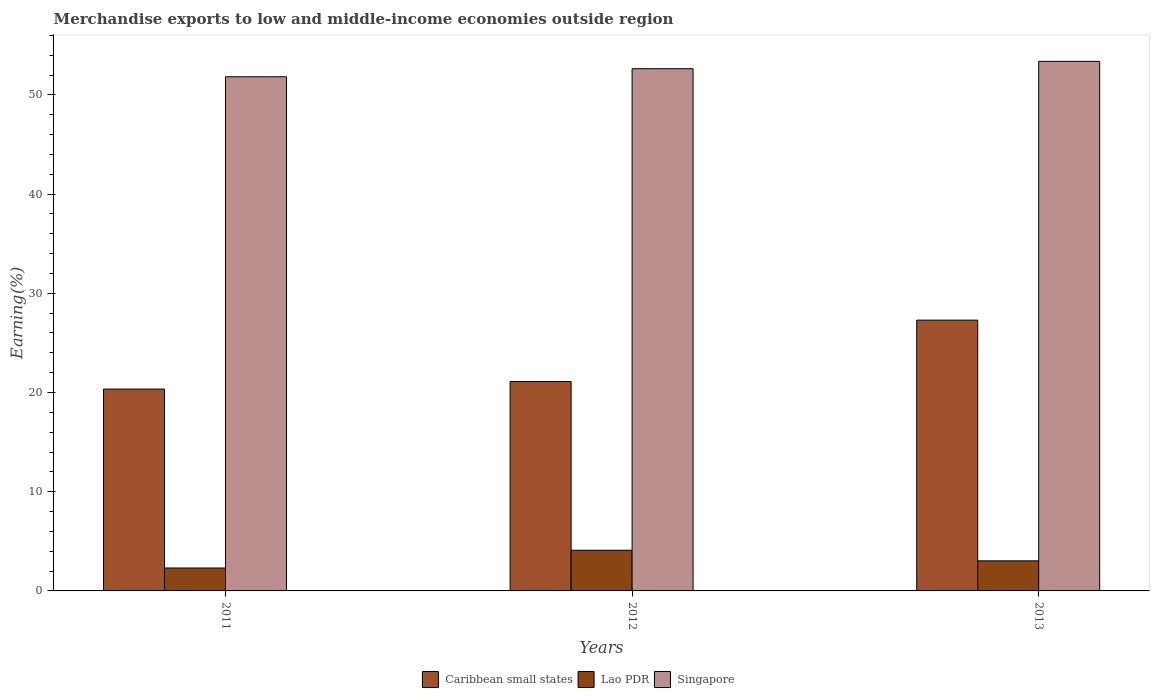How many groups of bars are there?
Ensure brevity in your answer.  3. Are the number of bars on each tick of the X-axis equal?
Give a very brief answer. Yes. How many bars are there on the 2nd tick from the left?
Your response must be concise. 3. What is the label of the 2nd group of bars from the left?
Keep it short and to the point. 2012. In how many cases, is the number of bars for a given year not equal to the number of legend labels?
Ensure brevity in your answer.  0. What is the percentage of amount earned from merchandise exports in Caribbean small states in 2013?
Offer a very short reply. 27.3. Across all years, what is the maximum percentage of amount earned from merchandise exports in Lao PDR?
Provide a succinct answer. 4.1. Across all years, what is the minimum percentage of amount earned from merchandise exports in Caribbean small states?
Ensure brevity in your answer.  20.35. In which year was the percentage of amount earned from merchandise exports in Caribbean small states minimum?
Your response must be concise. 2011. What is the total percentage of amount earned from merchandise exports in Singapore in the graph?
Your answer should be compact. 157.85. What is the difference between the percentage of amount earned from merchandise exports in Caribbean small states in 2011 and that in 2012?
Your answer should be very brief. -0.76. What is the difference between the percentage of amount earned from merchandise exports in Singapore in 2011 and the percentage of amount earned from merchandise exports in Lao PDR in 2012?
Your answer should be very brief. 47.73. What is the average percentage of amount earned from merchandise exports in Singapore per year?
Ensure brevity in your answer.  52.62. In the year 2013, what is the difference between the percentage of amount earned from merchandise exports in Singapore and percentage of amount earned from merchandise exports in Lao PDR?
Keep it short and to the point. 50.35. What is the ratio of the percentage of amount earned from merchandise exports in Caribbean small states in 2011 to that in 2012?
Your answer should be very brief. 0.96. Is the percentage of amount earned from merchandise exports in Caribbean small states in 2011 less than that in 2012?
Your answer should be very brief. Yes. Is the difference between the percentage of amount earned from merchandise exports in Singapore in 2011 and 2012 greater than the difference between the percentage of amount earned from merchandise exports in Lao PDR in 2011 and 2012?
Your answer should be compact. Yes. What is the difference between the highest and the second highest percentage of amount earned from merchandise exports in Singapore?
Offer a terse response. 0.74. What is the difference between the highest and the lowest percentage of amount earned from merchandise exports in Singapore?
Your answer should be compact. 1.55. Is the sum of the percentage of amount earned from merchandise exports in Caribbean small states in 2012 and 2013 greater than the maximum percentage of amount earned from merchandise exports in Singapore across all years?
Ensure brevity in your answer.  No. What does the 1st bar from the left in 2013 represents?
Give a very brief answer. Caribbean small states. What does the 1st bar from the right in 2013 represents?
Offer a very short reply. Singapore. How many bars are there?
Offer a terse response. 9. How many years are there in the graph?
Your answer should be compact. 3. What is the difference between two consecutive major ticks on the Y-axis?
Make the answer very short. 10. Are the values on the major ticks of Y-axis written in scientific E-notation?
Ensure brevity in your answer.  No. Does the graph contain grids?
Your answer should be compact. No. Where does the legend appear in the graph?
Your answer should be very brief. Bottom center. How many legend labels are there?
Make the answer very short. 3. How are the legend labels stacked?
Keep it short and to the point. Horizontal. What is the title of the graph?
Provide a succinct answer. Merchandise exports to low and middle-income economies outside region. Does "Papua New Guinea" appear as one of the legend labels in the graph?
Keep it short and to the point. No. What is the label or title of the X-axis?
Provide a short and direct response. Years. What is the label or title of the Y-axis?
Provide a short and direct response. Earning(%). What is the Earning(%) of Caribbean small states in 2011?
Make the answer very short. 20.35. What is the Earning(%) of Lao PDR in 2011?
Provide a short and direct response. 2.31. What is the Earning(%) in Singapore in 2011?
Your response must be concise. 51.83. What is the Earning(%) in Caribbean small states in 2012?
Keep it short and to the point. 21.1. What is the Earning(%) in Lao PDR in 2012?
Ensure brevity in your answer.  4.1. What is the Earning(%) in Singapore in 2012?
Your answer should be compact. 52.64. What is the Earning(%) in Caribbean small states in 2013?
Ensure brevity in your answer.  27.3. What is the Earning(%) of Lao PDR in 2013?
Provide a succinct answer. 3.03. What is the Earning(%) of Singapore in 2013?
Your answer should be very brief. 53.38. Across all years, what is the maximum Earning(%) in Caribbean small states?
Offer a very short reply. 27.3. Across all years, what is the maximum Earning(%) in Lao PDR?
Give a very brief answer. 4.1. Across all years, what is the maximum Earning(%) of Singapore?
Provide a short and direct response. 53.38. Across all years, what is the minimum Earning(%) of Caribbean small states?
Your response must be concise. 20.35. Across all years, what is the minimum Earning(%) in Lao PDR?
Provide a short and direct response. 2.31. Across all years, what is the minimum Earning(%) in Singapore?
Provide a succinct answer. 51.83. What is the total Earning(%) in Caribbean small states in the graph?
Your answer should be compact. 68.75. What is the total Earning(%) of Lao PDR in the graph?
Make the answer very short. 9.44. What is the total Earning(%) of Singapore in the graph?
Provide a short and direct response. 157.85. What is the difference between the Earning(%) of Caribbean small states in 2011 and that in 2012?
Offer a terse response. -0.76. What is the difference between the Earning(%) in Lao PDR in 2011 and that in 2012?
Your answer should be very brief. -1.79. What is the difference between the Earning(%) in Singapore in 2011 and that in 2012?
Your response must be concise. -0.81. What is the difference between the Earning(%) in Caribbean small states in 2011 and that in 2013?
Your response must be concise. -6.95. What is the difference between the Earning(%) in Lao PDR in 2011 and that in 2013?
Keep it short and to the point. -0.72. What is the difference between the Earning(%) in Singapore in 2011 and that in 2013?
Keep it short and to the point. -1.55. What is the difference between the Earning(%) in Caribbean small states in 2012 and that in 2013?
Your answer should be compact. -6.19. What is the difference between the Earning(%) in Lao PDR in 2012 and that in 2013?
Give a very brief answer. 1.07. What is the difference between the Earning(%) in Singapore in 2012 and that in 2013?
Provide a short and direct response. -0.74. What is the difference between the Earning(%) of Caribbean small states in 2011 and the Earning(%) of Lao PDR in 2012?
Offer a terse response. 16.25. What is the difference between the Earning(%) of Caribbean small states in 2011 and the Earning(%) of Singapore in 2012?
Give a very brief answer. -32.29. What is the difference between the Earning(%) of Lao PDR in 2011 and the Earning(%) of Singapore in 2012?
Your answer should be very brief. -50.33. What is the difference between the Earning(%) in Caribbean small states in 2011 and the Earning(%) in Lao PDR in 2013?
Your answer should be compact. 17.31. What is the difference between the Earning(%) of Caribbean small states in 2011 and the Earning(%) of Singapore in 2013?
Make the answer very short. -33.03. What is the difference between the Earning(%) of Lao PDR in 2011 and the Earning(%) of Singapore in 2013?
Offer a very short reply. -51.07. What is the difference between the Earning(%) of Caribbean small states in 2012 and the Earning(%) of Lao PDR in 2013?
Keep it short and to the point. 18.07. What is the difference between the Earning(%) in Caribbean small states in 2012 and the Earning(%) in Singapore in 2013?
Your response must be concise. -32.27. What is the difference between the Earning(%) of Lao PDR in 2012 and the Earning(%) of Singapore in 2013?
Your answer should be very brief. -49.28. What is the average Earning(%) in Caribbean small states per year?
Your answer should be very brief. 22.92. What is the average Earning(%) in Lao PDR per year?
Offer a terse response. 3.15. What is the average Earning(%) in Singapore per year?
Provide a succinct answer. 52.62. In the year 2011, what is the difference between the Earning(%) in Caribbean small states and Earning(%) in Lao PDR?
Give a very brief answer. 18.04. In the year 2011, what is the difference between the Earning(%) in Caribbean small states and Earning(%) in Singapore?
Offer a very short reply. -31.48. In the year 2011, what is the difference between the Earning(%) in Lao PDR and Earning(%) in Singapore?
Ensure brevity in your answer.  -49.52. In the year 2012, what is the difference between the Earning(%) of Caribbean small states and Earning(%) of Lao PDR?
Ensure brevity in your answer.  17. In the year 2012, what is the difference between the Earning(%) of Caribbean small states and Earning(%) of Singapore?
Your response must be concise. -31.53. In the year 2012, what is the difference between the Earning(%) in Lao PDR and Earning(%) in Singapore?
Your answer should be very brief. -48.54. In the year 2013, what is the difference between the Earning(%) in Caribbean small states and Earning(%) in Lao PDR?
Your response must be concise. 24.26. In the year 2013, what is the difference between the Earning(%) in Caribbean small states and Earning(%) in Singapore?
Give a very brief answer. -26.08. In the year 2013, what is the difference between the Earning(%) of Lao PDR and Earning(%) of Singapore?
Make the answer very short. -50.35. What is the ratio of the Earning(%) in Lao PDR in 2011 to that in 2012?
Your answer should be compact. 0.56. What is the ratio of the Earning(%) of Singapore in 2011 to that in 2012?
Provide a succinct answer. 0.98. What is the ratio of the Earning(%) in Caribbean small states in 2011 to that in 2013?
Offer a terse response. 0.75. What is the ratio of the Earning(%) of Lao PDR in 2011 to that in 2013?
Your answer should be very brief. 0.76. What is the ratio of the Earning(%) of Singapore in 2011 to that in 2013?
Make the answer very short. 0.97. What is the ratio of the Earning(%) in Caribbean small states in 2012 to that in 2013?
Offer a very short reply. 0.77. What is the ratio of the Earning(%) of Lao PDR in 2012 to that in 2013?
Ensure brevity in your answer.  1.35. What is the ratio of the Earning(%) in Singapore in 2012 to that in 2013?
Your answer should be very brief. 0.99. What is the difference between the highest and the second highest Earning(%) of Caribbean small states?
Ensure brevity in your answer.  6.19. What is the difference between the highest and the second highest Earning(%) in Lao PDR?
Make the answer very short. 1.07. What is the difference between the highest and the second highest Earning(%) of Singapore?
Offer a terse response. 0.74. What is the difference between the highest and the lowest Earning(%) in Caribbean small states?
Ensure brevity in your answer.  6.95. What is the difference between the highest and the lowest Earning(%) in Lao PDR?
Offer a very short reply. 1.79. What is the difference between the highest and the lowest Earning(%) of Singapore?
Provide a succinct answer. 1.55. 